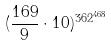Convert formula to latex. <formula><loc_0><loc_0><loc_500><loc_500>( \frac { 1 6 9 } { 9 } \cdot 1 0 ) ^ { 3 6 2 ^ { 4 6 8 } }</formula> 